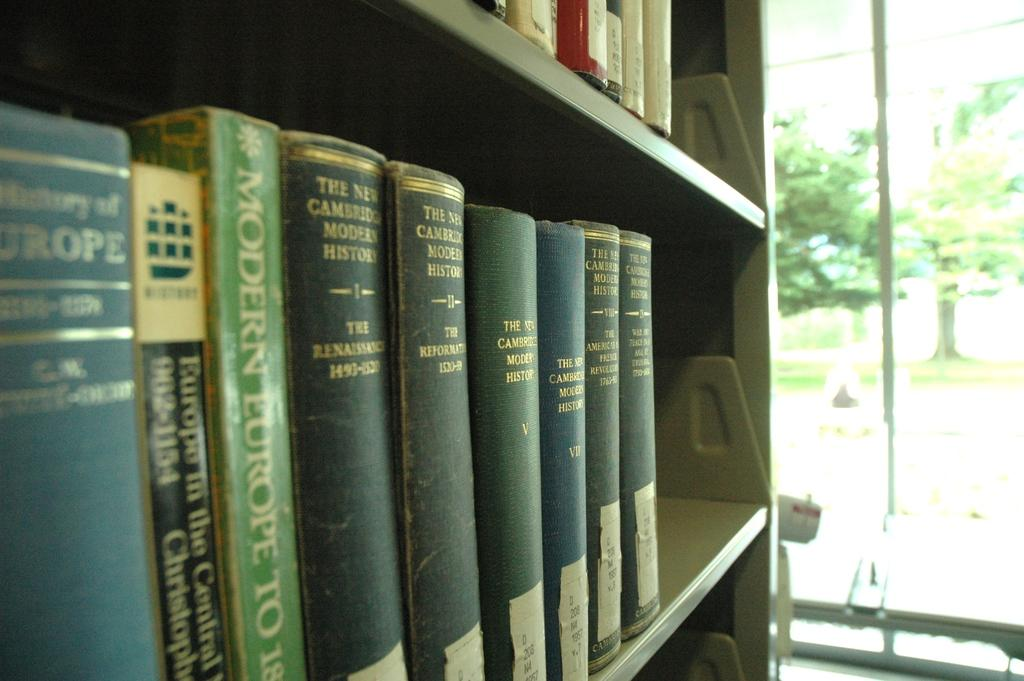<image>
Relay a brief, clear account of the picture shown. Blue and green colored books are on a bookshelf in a room. 